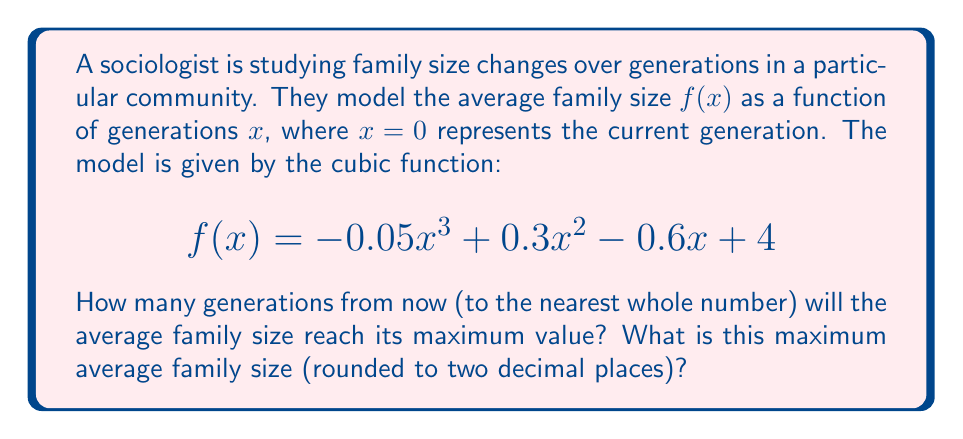Teach me how to tackle this problem. To solve this problem, we need to follow these steps:

1) First, we need to find the derivative of the function $f(x)$ to determine where the maximum occurs:

   $$f'(x) = -0.15x^2 + 0.6x - 0.6$$

2) The maximum occurs where $f'(x) = 0$. So we need to solve the quadratic equation:

   $$-0.15x^2 + 0.6x - 0.6 = 0$$

3) We can solve this using the quadratic formula: $x = \frac{-b \pm \sqrt{b^2 - 4ac}}{2a}$

   Where $a = -0.15$, $b = 0.6$, and $c = -0.6$

4) Plugging these values into the quadratic formula:

   $$x = \frac{-0.6 \pm \sqrt{0.6^2 - 4(-0.15)(-0.6)}}{2(-0.15)}$$

   $$= \frac{-0.6 \pm \sqrt{0.36 - 0.36}}{-0.3}$$

   $$= \frac{-0.6 \pm 0}{-0.3} = 2$$

5) This means the maximum occurs 2 generations from now.

6) To find the maximum value, we plug $x=2$ back into the original function:

   $$f(2) = -0.05(2)^3 + 0.3(2)^2 - 0.6(2) + 4$$
   
   $$= -0.4 + 1.2 - 1.2 + 4 = 3.6$$

Therefore, the maximum average family size is 3.60 (rounded to two decimal places).
Answer: The average family size will reach its maximum value 2 generations from now, and the maximum average family size will be 3.60. 